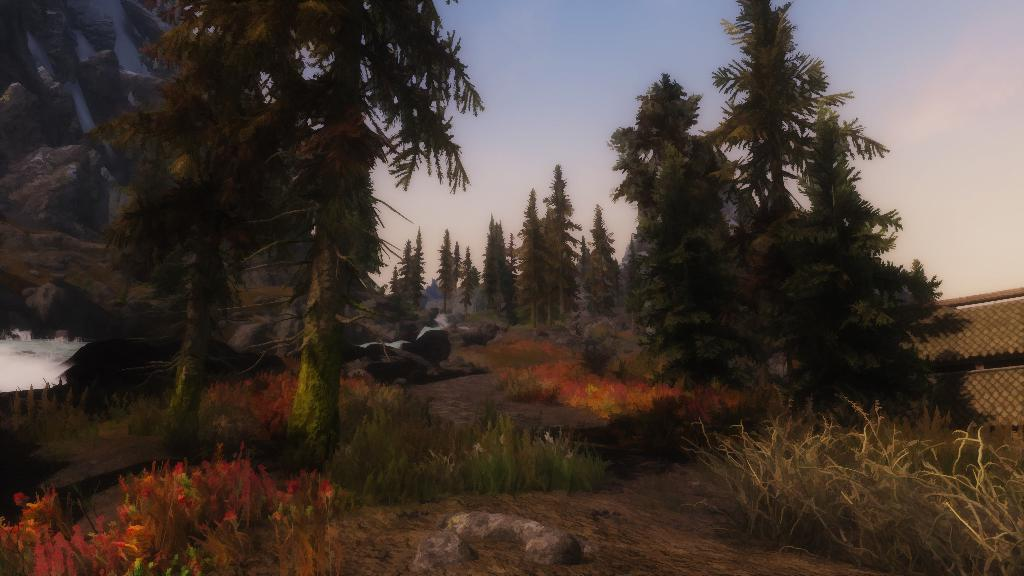What type of scene is shown in the image? The image depicts a nature scene. What are the main features of the nature scene? There are many huge trees in the image. Can you spot any small objects in the image? Yes, there is a small stone visible in the image. What is the condition of the watch in the image? There is no watch present in the image. Can you describe the toad's color in the image? There is no toad present in the image. 